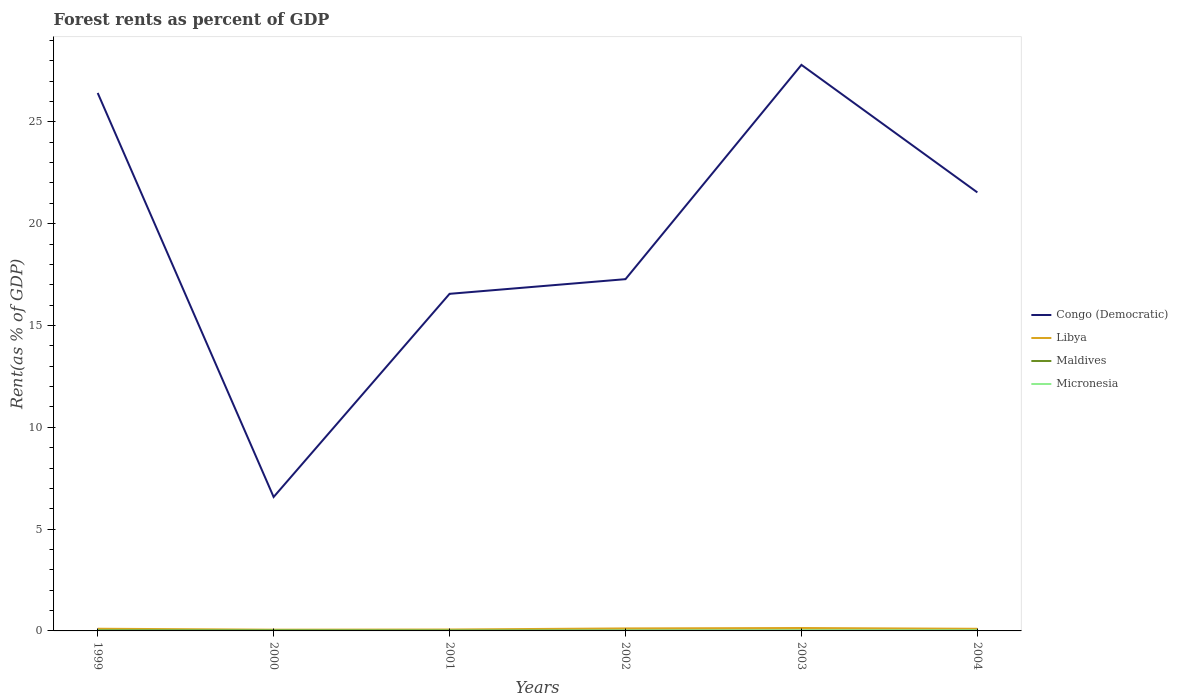Is the number of lines equal to the number of legend labels?
Provide a short and direct response. Yes. Across all years, what is the maximum forest rent in Congo (Democratic)?
Keep it short and to the point. 6.58. In which year was the forest rent in Micronesia maximum?
Provide a short and direct response. 1999. What is the total forest rent in Maldives in the graph?
Provide a succinct answer. 0. What is the difference between the highest and the second highest forest rent in Micronesia?
Offer a very short reply. 0.02. What is the difference between the highest and the lowest forest rent in Libya?
Ensure brevity in your answer.  4. Is the forest rent in Micronesia strictly greater than the forest rent in Maldives over the years?
Provide a short and direct response. No. How many lines are there?
Your response must be concise. 4. Are the values on the major ticks of Y-axis written in scientific E-notation?
Your answer should be very brief. No. Does the graph contain any zero values?
Your answer should be very brief. No. Does the graph contain grids?
Keep it short and to the point. No. How are the legend labels stacked?
Provide a succinct answer. Vertical. What is the title of the graph?
Provide a succinct answer. Forest rents as percent of GDP. Does "Barbados" appear as one of the legend labels in the graph?
Your answer should be very brief. No. What is the label or title of the X-axis?
Keep it short and to the point. Years. What is the label or title of the Y-axis?
Keep it short and to the point. Rent(as % of GDP). What is the Rent(as % of GDP) in Congo (Democratic) in 1999?
Give a very brief answer. 26.42. What is the Rent(as % of GDP) of Libya in 1999?
Give a very brief answer. 0.11. What is the Rent(as % of GDP) in Maldives in 1999?
Provide a succinct answer. 0.04. What is the Rent(as % of GDP) in Micronesia in 1999?
Provide a succinct answer. 0.01. What is the Rent(as % of GDP) in Congo (Democratic) in 2000?
Make the answer very short. 6.58. What is the Rent(as % of GDP) of Libya in 2000?
Your answer should be compact. 0.06. What is the Rent(as % of GDP) in Maldives in 2000?
Provide a short and direct response. 0.04. What is the Rent(as % of GDP) in Micronesia in 2000?
Keep it short and to the point. 0.01. What is the Rent(as % of GDP) of Congo (Democratic) in 2001?
Offer a terse response. 16.56. What is the Rent(as % of GDP) of Libya in 2001?
Provide a succinct answer. 0.07. What is the Rent(as % of GDP) of Maldives in 2001?
Provide a short and direct response. 0.03. What is the Rent(as % of GDP) of Micronesia in 2001?
Ensure brevity in your answer.  0.01. What is the Rent(as % of GDP) in Congo (Democratic) in 2002?
Make the answer very short. 17.28. What is the Rent(as % of GDP) in Libya in 2002?
Ensure brevity in your answer.  0.12. What is the Rent(as % of GDP) in Maldives in 2002?
Keep it short and to the point. 0.03. What is the Rent(as % of GDP) of Micronesia in 2002?
Provide a succinct answer. 0.01. What is the Rent(as % of GDP) in Congo (Democratic) in 2003?
Give a very brief answer. 27.8. What is the Rent(as % of GDP) in Libya in 2003?
Offer a terse response. 0.14. What is the Rent(as % of GDP) of Maldives in 2003?
Keep it short and to the point. 0.03. What is the Rent(as % of GDP) of Micronesia in 2003?
Provide a succinct answer. 0.02. What is the Rent(as % of GDP) of Congo (Democratic) in 2004?
Keep it short and to the point. 21.54. What is the Rent(as % of GDP) in Libya in 2004?
Your answer should be very brief. 0.11. What is the Rent(as % of GDP) of Maldives in 2004?
Provide a succinct answer. 0.02. What is the Rent(as % of GDP) of Micronesia in 2004?
Provide a succinct answer. 0.03. Across all years, what is the maximum Rent(as % of GDP) in Congo (Democratic)?
Provide a short and direct response. 27.8. Across all years, what is the maximum Rent(as % of GDP) in Libya?
Make the answer very short. 0.14. Across all years, what is the maximum Rent(as % of GDP) in Maldives?
Offer a very short reply. 0.04. Across all years, what is the maximum Rent(as % of GDP) of Micronesia?
Provide a short and direct response. 0.03. Across all years, what is the minimum Rent(as % of GDP) in Congo (Democratic)?
Offer a terse response. 6.58. Across all years, what is the minimum Rent(as % of GDP) in Libya?
Keep it short and to the point. 0.06. Across all years, what is the minimum Rent(as % of GDP) in Maldives?
Provide a short and direct response. 0.02. Across all years, what is the minimum Rent(as % of GDP) of Micronesia?
Keep it short and to the point. 0.01. What is the total Rent(as % of GDP) of Congo (Democratic) in the graph?
Offer a terse response. 116.17. What is the total Rent(as % of GDP) of Libya in the graph?
Your answer should be very brief. 0.61. What is the total Rent(as % of GDP) of Maldives in the graph?
Offer a very short reply. 0.18. What is the total Rent(as % of GDP) in Micronesia in the graph?
Give a very brief answer. 0.1. What is the difference between the Rent(as % of GDP) of Congo (Democratic) in 1999 and that in 2000?
Provide a short and direct response. 19.84. What is the difference between the Rent(as % of GDP) in Libya in 1999 and that in 2000?
Keep it short and to the point. 0.05. What is the difference between the Rent(as % of GDP) of Maldives in 1999 and that in 2000?
Ensure brevity in your answer.  0. What is the difference between the Rent(as % of GDP) in Micronesia in 1999 and that in 2000?
Ensure brevity in your answer.  -0. What is the difference between the Rent(as % of GDP) in Congo (Democratic) in 1999 and that in 2001?
Offer a very short reply. 9.87. What is the difference between the Rent(as % of GDP) in Libya in 1999 and that in 2001?
Provide a succinct answer. 0.04. What is the difference between the Rent(as % of GDP) in Maldives in 1999 and that in 2001?
Your answer should be compact. 0.01. What is the difference between the Rent(as % of GDP) of Micronesia in 1999 and that in 2001?
Your answer should be compact. -0. What is the difference between the Rent(as % of GDP) in Congo (Democratic) in 1999 and that in 2002?
Give a very brief answer. 9.14. What is the difference between the Rent(as % of GDP) in Libya in 1999 and that in 2002?
Keep it short and to the point. -0.02. What is the difference between the Rent(as % of GDP) of Maldives in 1999 and that in 2002?
Provide a short and direct response. 0.01. What is the difference between the Rent(as % of GDP) of Micronesia in 1999 and that in 2002?
Give a very brief answer. -0. What is the difference between the Rent(as % of GDP) of Congo (Democratic) in 1999 and that in 2003?
Make the answer very short. -1.38. What is the difference between the Rent(as % of GDP) of Libya in 1999 and that in 2003?
Your response must be concise. -0.04. What is the difference between the Rent(as % of GDP) of Maldives in 1999 and that in 2003?
Give a very brief answer. 0.01. What is the difference between the Rent(as % of GDP) of Micronesia in 1999 and that in 2003?
Your answer should be compact. -0.01. What is the difference between the Rent(as % of GDP) of Congo (Democratic) in 1999 and that in 2004?
Make the answer very short. 4.88. What is the difference between the Rent(as % of GDP) of Libya in 1999 and that in 2004?
Provide a succinct answer. 0. What is the difference between the Rent(as % of GDP) in Maldives in 1999 and that in 2004?
Make the answer very short. 0.01. What is the difference between the Rent(as % of GDP) of Micronesia in 1999 and that in 2004?
Offer a terse response. -0.02. What is the difference between the Rent(as % of GDP) in Congo (Democratic) in 2000 and that in 2001?
Your answer should be very brief. -9.98. What is the difference between the Rent(as % of GDP) in Libya in 2000 and that in 2001?
Keep it short and to the point. -0.01. What is the difference between the Rent(as % of GDP) of Maldives in 2000 and that in 2001?
Provide a short and direct response. 0.01. What is the difference between the Rent(as % of GDP) in Micronesia in 2000 and that in 2001?
Ensure brevity in your answer.  -0. What is the difference between the Rent(as % of GDP) in Congo (Democratic) in 2000 and that in 2002?
Keep it short and to the point. -10.7. What is the difference between the Rent(as % of GDP) of Libya in 2000 and that in 2002?
Your answer should be compact. -0.06. What is the difference between the Rent(as % of GDP) in Maldives in 2000 and that in 2002?
Offer a very short reply. 0.01. What is the difference between the Rent(as % of GDP) in Micronesia in 2000 and that in 2002?
Your answer should be compact. -0. What is the difference between the Rent(as % of GDP) in Congo (Democratic) in 2000 and that in 2003?
Offer a very short reply. -21.22. What is the difference between the Rent(as % of GDP) of Libya in 2000 and that in 2003?
Give a very brief answer. -0.08. What is the difference between the Rent(as % of GDP) in Maldives in 2000 and that in 2003?
Give a very brief answer. 0.01. What is the difference between the Rent(as % of GDP) in Micronesia in 2000 and that in 2003?
Make the answer very short. -0.01. What is the difference between the Rent(as % of GDP) of Congo (Democratic) in 2000 and that in 2004?
Ensure brevity in your answer.  -14.96. What is the difference between the Rent(as % of GDP) of Libya in 2000 and that in 2004?
Give a very brief answer. -0.04. What is the difference between the Rent(as % of GDP) of Maldives in 2000 and that in 2004?
Your response must be concise. 0.01. What is the difference between the Rent(as % of GDP) of Micronesia in 2000 and that in 2004?
Your answer should be very brief. -0.01. What is the difference between the Rent(as % of GDP) of Congo (Democratic) in 2001 and that in 2002?
Your response must be concise. -0.72. What is the difference between the Rent(as % of GDP) in Libya in 2001 and that in 2002?
Give a very brief answer. -0.05. What is the difference between the Rent(as % of GDP) in Maldives in 2001 and that in 2002?
Your answer should be compact. 0. What is the difference between the Rent(as % of GDP) in Micronesia in 2001 and that in 2002?
Ensure brevity in your answer.  -0. What is the difference between the Rent(as % of GDP) of Congo (Democratic) in 2001 and that in 2003?
Provide a short and direct response. -11.25. What is the difference between the Rent(as % of GDP) in Libya in 2001 and that in 2003?
Provide a succinct answer. -0.07. What is the difference between the Rent(as % of GDP) in Maldives in 2001 and that in 2003?
Make the answer very short. 0. What is the difference between the Rent(as % of GDP) in Micronesia in 2001 and that in 2003?
Your answer should be compact. -0.01. What is the difference between the Rent(as % of GDP) of Congo (Democratic) in 2001 and that in 2004?
Provide a succinct answer. -4.98. What is the difference between the Rent(as % of GDP) in Libya in 2001 and that in 2004?
Your answer should be compact. -0.04. What is the difference between the Rent(as % of GDP) in Maldives in 2001 and that in 2004?
Your answer should be very brief. 0. What is the difference between the Rent(as % of GDP) in Micronesia in 2001 and that in 2004?
Give a very brief answer. -0.01. What is the difference between the Rent(as % of GDP) of Congo (Democratic) in 2002 and that in 2003?
Keep it short and to the point. -10.52. What is the difference between the Rent(as % of GDP) of Libya in 2002 and that in 2003?
Offer a very short reply. -0.02. What is the difference between the Rent(as % of GDP) of Maldives in 2002 and that in 2003?
Ensure brevity in your answer.  0. What is the difference between the Rent(as % of GDP) of Micronesia in 2002 and that in 2003?
Offer a terse response. -0.01. What is the difference between the Rent(as % of GDP) of Congo (Democratic) in 2002 and that in 2004?
Offer a very short reply. -4.26. What is the difference between the Rent(as % of GDP) of Libya in 2002 and that in 2004?
Give a very brief answer. 0.02. What is the difference between the Rent(as % of GDP) of Maldives in 2002 and that in 2004?
Ensure brevity in your answer.  0. What is the difference between the Rent(as % of GDP) of Micronesia in 2002 and that in 2004?
Your response must be concise. -0.01. What is the difference between the Rent(as % of GDP) in Congo (Democratic) in 2003 and that in 2004?
Offer a terse response. 6.26. What is the difference between the Rent(as % of GDP) in Libya in 2003 and that in 2004?
Provide a succinct answer. 0.04. What is the difference between the Rent(as % of GDP) in Maldives in 2003 and that in 2004?
Make the answer very short. 0. What is the difference between the Rent(as % of GDP) of Micronesia in 2003 and that in 2004?
Offer a very short reply. -0. What is the difference between the Rent(as % of GDP) in Congo (Democratic) in 1999 and the Rent(as % of GDP) in Libya in 2000?
Give a very brief answer. 26.36. What is the difference between the Rent(as % of GDP) in Congo (Democratic) in 1999 and the Rent(as % of GDP) in Maldives in 2000?
Your answer should be compact. 26.38. What is the difference between the Rent(as % of GDP) in Congo (Democratic) in 1999 and the Rent(as % of GDP) in Micronesia in 2000?
Make the answer very short. 26.41. What is the difference between the Rent(as % of GDP) in Libya in 1999 and the Rent(as % of GDP) in Maldives in 2000?
Offer a terse response. 0.07. What is the difference between the Rent(as % of GDP) of Libya in 1999 and the Rent(as % of GDP) of Micronesia in 2000?
Give a very brief answer. 0.1. What is the difference between the Rent(as % of GDP) in Maldives in 1999 and the Rent(as % of GDP) in Micronesia in 2000?
Provide a short and direct response. 0.03. What is the difference between the Rent(as % of GDP) of Congo (Democratic) in 1999 and the Rent(as % of GDP) of Libya in 2001?
Provide a succinct answer. 26.35. What is the difference between the Rent(as % of GDP) in Congo (Democratic) in 1999 and the Rent(as % of GDP) in Maldives in 2001?
Keep it short and to the point. 26.39. What is the difference between the Rent(as % of GDP) of Congo (Democratic) in 1999 and the Rent(as % of GDP) of Micronesia in 2001?
Ensure brevity in your answer.  26.41. What is the difference between the Rent(as % of GDP) in Libya in 1999 and the Rent(as % of GDP) in Maldives in 2001?
Your answer should be compact. 0.08. What is the difference between the Rent(as % of GDP) in Libya in 1999 and the Rent(as % of GDP) in Micronesia in 2001?
Keep it short and to the point. 0.1. What is the difference between the Rent(as % of GDP) in Maldives in 1999 and the Rent(as % of GDP) in Micronesia in 2001?
Provide a short and direct response. 0.03. What is the difference between the Rent(as % of GDP) in Congo (Democratic) in 1999 and the Rent(as % of GDP) in Libya in 2002?
Your response must be concise. 26.3. What is the difference between the Rent(as % of GDP) of Congo (Democratic) in 1999 and the Rent(as % of GDP) of Maldives in 2002?
Offer a terse response. 26.39. What is the difference between the Rent(as % of GDP) of Congo (Democratic) in 1999 and the Rent(as % of GDP) of Micronesia in 2002?
Keep it short and to the point. 26.41. What is the difference between the Rent(as % of GDP) in Libya in 1999 and the Rent(as % of GDP) in Maldives in 2002?
Make the answer very short. 0.08. What is the difference between the Rent(as % of GDP) in Libya in 1999 and the Rent(as % of GDP) in Micronesia in 2002?
Offer a very short reply. 0.09. What is the difference between the Rent(as % of GDP) in Maldives in 1999 and the Rent(as % of GDP) in Micronesia in 2002?
Make the answer very short. 0.02. What is the difference between the Rent(as % of GDP) in Congo (Democratic) in 1999 and the Rent(as % of GDP) in Libya in 2003?
Provide a succinct answer. 26.28. What is the difference between the Rent(as % of GDP) of Congo (Democratic) in 1999 and the Rent(as % of GDP) of Maldives in 2003?
Provide a succinct answer. 26.39. What is the difference between the Rent(as % of GDP) in Congo (Democratic) in 1999 and the Rent(as % of GDP) in Micronesia in 2003?
Your answer should be compact. 26.4. What is the difference between the Rent(as % of GDP) in Libya in 1999 and the Rent(as % of GDP) in Maldives in 2003?
Offer a very short reply. 0.08. What is the difference between the Rent(as % of GDP) in Libya in 1999 and the Rent(as % of GDP) in Micronesia in 2003?
Ensure brevity in your answer.  0.09. What is the difference between the Rent(as % of GDP) in Maldives in 1999 and the Rent(as % of GDP) in Micronesia in 2003?
Keep it short and to the point. 0.02. What is the difference between the Rent(as % of GDP) in Congo (Democratic) in 1999 and the Rent(as % of GDP) in Libya in 2004?
Your answer should be very brief. 26.32. What is the difference between the Rent(as % of GDP) of Congo (Democratic) in 1999 and the Rent(as % of GDP) of Maldives in 2004?
Offer a terse response. 26.4. What is the difference between the Rent(as % of GDP) of Congo (Democratic) in 1999 and the Rent(as % of GDP) of Micronesia in 2004?
Your response must be concise. 26.39. What is the difference between the Rent(as % of GDP) in Libya in 1999 and the Rent(as % of GDP) in Maldives in 2004?
Ensure brevity in your answer.  0.08. What is the difference between the Rent(as % of GDP) of Libya in 1999 and the Rent(as % of GDP) of Micronesia in 2004?
Make the answer very short. 0.08. What is the difference between the Rent(as % of GDP) in Maldives in 1999 and the Rent(as % of GDP) in Micronesia in 2004?
Provide a short and direct response. 0.01. What is the difference between the Rent(as % of GDP) in Congo (Democratic) in 2000 and the Rent(as % of GDP) in Libya in 2001?
Your answer should be very brief. 6.51. What is the difference between the Rent(as % of GDP) in Congo (Democratic) in 2000 and the Rent(as % of GDP) in Maldives in 2001?
Your response must be concise. 6.55. What is the difference between the Rent(as % of GDP) in Congo (Democratic) in 2000 and the Rent(as % of GDP) in Micronesia in 2001?
Ensure brevity in your answer.  6.57. What is the difference between the Rent(as % of GDP) of Libya in 2000 and the Rent(as % of GDP) of Maldives in 2001?
Keep it short and to the point. 0.03. What is the difference between the Rent(as % of GDP) in Libya in 2000 and the Rent(as % of GDP) in Micronesia in 2001?
Ensure brevity in your answer.  0.05. What is the difference between the Rent(as % of GDP) in Maldives in 2000 and the Rent(as % of GDP) in Micronesia in 2001?
Offer a terse response. 0.03. What is the difference between the Rent(as % of GDP) of Congo (Democratic) in 2000 and the Rent(as % of GDP) of Libya in 2002?
Provide a succinct answer. 6.45. What is the difference between the Rent(as % of GDP) of Congo (Democratic) in 2000 and the Rent(as % of GDP) of Maldives in 2002?
Ensure brevity in your answer.  6.55. What is the difference between the Rent(as % of GDP) in Congo (Democratic) in 2000 and the Rent(as % of GDP) in Micronesia in 2002?
Keep it short and to the point. 6.56. What is the difference between the Rent(as % of GDP) of Libya in 2000 and the Rent(as % of GDP) of Maldives in 2002?
Offer a terse response. 0.03. What is the difference between the Rent(as % of GDP) in Libya in 2000 and the Rent(as % of GDP) in Micronesia in 2002?
Provide a short and direct response. 0.05. What is the difference between the Rent(as % of GDP) in Maldives in 2000 and the Rent(as % of GDP) in Micronesia in 2002?
Your response must be concise. 0.02. What is the difference between the Rent(as % of GDP) in Congo (Democratic) in 2000 and the Rent(as % of GDP) in Libya in 2003?
Offer a terse response. 6.43. What is the difference between the Rent(as % of GDP) in Congo (Democratic) in 2000 and the Rent(as % of GDP) in Maldives in 2003?
Offer a very short reply. 6.55. What is the difference between the Rent(as % of GDP) of Congo (Democratic) in 2000 and the Rent(as % of GDP) of Micronesia in 2003?
Ensure brevity in your answer.  6.56. What is the difference between the Rent(as % of GDP) of Libya in 2000 and the Rent(as % of GDP) of Maldives in 2003?
Offer a very short reply. 0.03. What is the difference between the Rent(as % of GDP) of Libya in 2000 and the Rent(as % of GDP) of Micronesia in 2003?
Provide a short and direct response. 0.04. What is the difference between the Rent(as % of GDP) in Maldives in 2000 and the Rent(as % of GDP) in Micronesia in 2003?
Your answer should be compact. 0.01. What is the difference between the Rent(as % of GDP) in Congo (Democratic) in 2000 and the Rent(as % of GDP) in Libya in 2004?
Your answer should be compact. 6.47. What is the difference between the Rent(as % of GDP) of Congo (Democratic) in 2000 and the Rent(as % of GDP) of Maldives in 2004?
Offer a terse response. 6.55. What is the difference between the Rent(as % of GDP) of Congo (Democratic) in 2000 and the Rent(as % of GDP) of Micronesia in 2004?
Offer a terse response. 6.55. What is the difference between the Rent(as % of GDP) of Libya in 2000 and the Rent(as % of GDP) of Maldives in 2004?
Ensure brevity in your answer.  0.04. What is the difference between the Rent(as % of GDP) in Libya in 2000 and the Rent(as % of GDP) in Micronesia in 2004?
Provide a succinct answer. 0.03. What is the difference between the Rent(as % of GDP) in Maldives in 2000 and the Rent(as % of GDP) in Micronesia in 2004?
Make the answer very short. 0.01. What is the difference between the Rent(as % of GDP) of Congo (Democratic) in 2001 and the Rent(as % of GDP) of Libya in 2002?
Your answer should be very brief. 16.43. What is the difference between the Rent(as % of GDP) of Congo (Democratic) in 2001 and the Rent(as % of GDP) of Maldives in 2002?
Make the answer very short. 16.53. What is the difference between the Rent(as % of GDP) of Congo (Democratic) in 2001 and the Rent(as % of GDP) of Micronesia in 2002?
Your answer should be very brief. 16.54. What is the difference between the Rent(as % of GDP) in Libya in 2001 and the Rent(as % of GDP) in Maldives in 2002?
Provide a short and direct response. 0.04. What is the difference between the Rent(as % of GDP) of Libya in 2001 and the Rent(as % of GDP) of Micronesia in 2002?
Provide a succinct answer. 0.06. What is the difference between the Rent(as % of GDP) in Maldives in 2001 and the Rent(as % of GDP) in Micronesia in 2002?
Offer a terse response. 0.01. What is the difference between the Rent(as % of GDP) in Congo (Democratic) in 2001 and the Rent(as % of GDP) in Libya in 2003?
Your answer should be compact. 16.41. What is the difference between the Rent(as % of GDP) in Congo (Democratic) in 2001 and the Rent(as % of GDP) in Maldives in 2003?
Ensure brevity in your answer.  16.53. What is the difference between the Rent(as % of GDP) in Congo (Democratic) in 2001 and the Rent(as % of GDP) in Micronesia in 2003?
Provide a short and direct response. 16.53. What is the difference between the Rent(as % of GDP) in Libya in 2001 and the Rent(as % of GDP) in Maldives in 2003?
Your response must be concise. 0.04. What is the difference between the Rent(as % of GDP) of Libya in 2001 and the Rent(as % of GDP) of Micronesia in 2003?
Make the answer very short. 0.05. What is the difference between the Rent(as % of GDP) of Maldives in 2001 and the Rent(as % of GDP) of Micronesia in 2003?
Make the answer very short. 0. What is the difference between the Rent(as % of GDP) of Congo (Democratic) in 2001 and the Rent(as % of GDP) of Libya in 2004?
Your answer should be compact. 16.45. What is the difference between the Rent(as % of GDP) in Congo (Democratic) in 2001 and the Rent(as % of GDP) in Maldives in 2004?
Your answer should be very brief. 16.53. What is the difference between the Rent(as % of GDP) of Congo (Democratic) in 2001 and the Rent(as % of GDP) of Micronesia in 2004?
Make the answer very short. 16.53. What is the difference between the Rent(as % of GDP) in Libya in 2001 and the Rent(as % of GDP) in Maldives in 2004?
Keep it short and to the point. 0.04. What is the difference between the Rent(as % of GDP) of Libya in 2001 and the Rent(as % of GDP) of Micronesia in 2004?
Your answer should be very brief. 0.04. What is the difference between the Rent(as % of GDP) in Maldives in 2001 and the Rent(as % of GDP) in Micronesia in 2004?
Your response must be concise. 0. What is the difference between the Rent(as % of GDP) in Congo (Democratic) in 2002 and the Rent(as % of GDP) in Libya in 2003?
Ensure brevity in your answer.  17.13. What is the difference between the Rent(as % of GDP) in Congo (Democratic) in 2002 and the Rent(as % of GDP) in Maldives in 2003?
Provide a short and direct response. 17.25. What is the difference between the Rent(as % of GDP) in Congo (Democratic) in 2002 and the Rent(as % of GDP) in Micronesia in 2003?
Keep it short and to the point. 17.25. What is the difference between the Rent(as % of GDP) in Libya in 2002 and the Rent(as % of GDP) in Maldives in 2003?
Provide a short and direct response. 0.1. What is the difference between the Rent(as % of GDP) of Libya in 2002 and the Rent(as % of GDP) of Micronesia in 2003?
Provide a succinct answer. 0.1. What is the difference between the Rent(as % of GDP) of Maldives in 2002 and the Rent(as % of GDP) of Micronesia in 2003?
Provide a succinct answer. 0. What is the difference between the Rent(as % of GDP) of Congo (Democratic) in 2002 and the Rent(as % of GDP) of Libya in 2004?
Provide a succinct answer. 17.17. What is the difference between the Rent(as % of GDP) in Congo (Democratic) in 2002 and the Rent(as % of GDP) in Maldives in 2004?
Make the answer very short. 17.25. What is the difference between the Rent(as % of GDP) in Congo (Democratic) in 2002 and the Rent(as % of GDP) in Micronesia in 2004?
Your response must be concise. 17.25. What is the difference between the Rent(as % of GDP) in Libya in 2002 and the Rent(as % of GDP) in Maldives in 2004?
Provide a short and direct response. 0.1. What is the difference between the Rent(as % of GDP) of Libya in 2002 and the Rent(as % of GDP) of Micronesia in 2004?
Your response must be concise. 0.1. What is the difference between the Rent(as % of GDP) in Maldives in 2002 and the Rent(as % of GDP) in Micronesia in 2004?
Ensure brevity in your answer.  0. What is the difference between the Rent(as % of GDP) of Congo (Democratic) in 2003 and the Rent(as % of GDP) of Libya in 2004?
Your answer should be compact. 27.7. What is the difference between the Rent(as % of GDP) of Congo (Democratic) in 2003 and the Rent(as % of GDP) of Maldives in 2004?
Give a very brief answer. 27.78. What is the difference between the Rent(as % of GDP) in Congo (Democratic) in 2003 and the Rent(as % of GDP) in Micronesia in 2004?
Provide a succinct answer. 27.77. What is the difference between the Rent(as % of GDP) in Libya in 2003 and the Rent(as % of GDP) in Maldives in 2004?
Your answer should be very brief. 0.12. What is the difference between the Rent(as % of GDP) in Libya in 2003 and the Rent(as % of GDP) in Micronesia in 2004?
Offer a very short reply. 0.12. What is the average Rent(as % of GDP) in Congo (Democratic) per year?
Keep it short and to the point. 19.36. What is the average Rent(as % of GDP) in Libya per year?
Your answer should be very brief. 0.1. What is the average Rent(as % of GDP) in Maldives per year?
Provide a succinct answer. 0.03. What is the average Rent(as % of GDP) in Micronesia per year?
Provide a succinct answer. 0.02. In the year 1999, what is the difference between the Rent(as % of GDP) in Congo (Democratic) and Rent(as % of GDP) in Libya?
Your answer should be very brief. 26.31. In the year 1999, what is the difference between the Rent(as % of GDP) of Congo (Democratic) and Rent(as % of GDP) of Maldives?
Offer a terse response. 26.38. In the year 1999, what is the difference between the Rent(as % of GDP) in Congo (Democratic) and Rent(as % of GDP) in Micronesia?
Provide a short and direct response. 26.41. In the year 1999, what is the difference between the Rent(as % of GDP) in Libya and Rent(as % of GDP) in Maldives?
Your answer should be compact. 0.07. In the year 1999, what is the difference between the Rent(as % of GDP) of Libya and Rent(as % of GDP) of Micronesia?
Your response must be concise. 0.1. In the year 1999, what is the difference between the Rent(as % of GDP) in Maldives and Rent(as % of GDP) in Micronesia?
Offer a terse response. 0.03. In the year 2000, what is the difference between the Rent(as % of GDP) in Congo (Democratic) and Rent(as % of GDP) in Libya?
Provide a short and direct response. 6.52. In the year 2000, what is the difference between the Rent(as % of GDP) of Congo (Democratic) and Rent(as % of GDP) of Maldives?
Offer a very short reply. 6.54. In the year 2000, what is the difference between the Rent(as % of GDP) of Congo (Democratic) and Rent(as % of GDP) of Micronesia?
Provide a succinct answer. 6.57. In the year 2000, what is the difference between the Rent(as % of GDP) in Libya and Rent(as % of GDP) in Maldives?
Offer a very short reply. 0.02. In the year 2000, what is the difference between the Rent(as % of GDP) of Libya and Rent(as % of GDP) of Micronesia?
Keep it short and to the point. 0.05. In the year 2000, what is the difference between the Rent(as % of GDP) of Maldives and Rent(as % of GDP) of Micronesia?
Offer a very short reply. 0.03. In the year 2001, what is the difference between the Rent(as % of GDP) in Congo (Democratic) and Rent(as % of GDP) in Libya?
Give a very brief answer. 16.49. In the year 2001, what is the difference between the Rent(as % of GDP) in Congo (Democratic) and Rent(as % of GDP) in Maldives?
Your answer should be very brief. 16.53. In the year 2001, what is the difference between the Rent(as % of GDP) in Congo (Democratic) and Rent(as % of GDP) in Micronesia?
Offer a very short reply. 16.54. In the year 2001, what is the difference between the Rent(as % of GDP) of Libya and Rent(as % of GDP) of Maldives?
Provide a short and direct response. 0.04. In the year 2001, what is the difference between the Rent(as % of GDP) in Libya and Rent(as % of GDP) in Micronesia?
Provide a short and direct response. 0.06. In the year 2001, what is the difference between the Rent(as % of GDP) of Maldives and Rent(as % of GDP) of Micronesia?
Keep it short and to the point. 0.01. In the year 2002, what is the difference between the Rent(as % of GDP) of Congo (Democratic) and Rent(as % of GDP) of Libya?
Make the answer very short. 17.15. In the year 2002, what is the difference between the Rent(as % of GDP) of Congo (Democratic) and Rent(as % of GDP) of Maldives?
Provide a short and direct response. 17.25. In the year 2002, what is the difference between the Rent(as % of GDP) of Congo (Democratic) and Rent(as % of GDP) of Micronesia?
Make the answer very short. 17.26. In the year 2002, what is the difference between the Rent(as % of GDP) in Libya and Rent(as % of GDP) in Maldives?
Offer a very short reply. 0.1. In the year 2002, what is the difference between the Rent(as % of GDP) of Libya and Rent(as % of GDP) of Micronesia?
Your response must be concise. 0.11. In the year 2002, what is the difference between the Rent(as % of GDP) in Maldives and Rent(as % of GDP) in Micronesia?
Provide a short and direct response. 0.01. In the year 2003, what is the difference between the Rent(as % of GDP) of Congo (Democratic) and Rent(as % of GDP) of Libya?
Your answer should be compact. 27.66. In the year 2003, what is the difference between the Rent(as % of GDP) in Congo (Democratic) and Rent(as % of GDP) in Maldives?
Provide a succinct answer. 27.77. In the year 2003, what is the difference between the Rent(as % of GDP) in Congo (Democratic) and Rent(as % of GDP) in Micronesia?
Ensure brevity in your answer.  27.78. In the year 2003, what is the difference between the Rent(as % of GDP) in Libya and Rent(as % of GDP) in Maldives?
Your response must be concise. 0.12. In the year 2003, what is the difference between the Rent(as % of GDP) of Libya and Rent(as % of GDP) of Micronesia?
Your answer should be compact. 0.12. In the year 2003, what is the difference between the Rent(as % of GDP) of Maldives and Rent(as % of GDP) of Micronesia?
Give a very brief answer. 0. In the year 2004, what is the difference between the Rent(as % of GDP) in Congo (Democratic) and Rent(as % of GDP) in Libya?
Ensure brevity in your answer.  21.43. In the year 2004, what is the difference between the Rent(as % of GDP) of Congo (Democratic) and Rent(as % of GDP) of Maldives?
Give a very brief answer. 21.51. In the year 2004, what is the difference between the Rent(as % of GDP) of Congo (Democratic) and Rent(as % of GDP) of Micronesia?
Ensure brevity in your answer.  21.51. In the year 2004, what is the difference between the Rent(as % of GDP) in Libya and Rent(as % of GDP) in Maldives?
Your answer should be compact. 0.08. In the year 2004, what is the difference between the Rent(as % of GDP) in Libya and Rent(as % of GDP) in Micronesia?
Provide a succinct answer. 0.08. In the year 2004, what is the difference between the Rent(as % of GDP) in Maldives and Rent(as % of GDP) in Micronesia?
Your answer should be very brief. -0. What is the ratio of the Rent(as % of GDP) in Congo (Democratic) in 1999 to that in 2000?
Provide a short and direct response. 4.02. What is the ratio of the Rent(as % of GDP) of Libya in 1999 to that in 2000?
Keep it short and to the point. 1.78. What is the ratio of the Rent(as % of GDP) in Maldives in 1999 to that in 2000?
Your answer should be very brief. 1.01. What is the ratio of the Rent(as % of GDP) of Micronesia in 1999 to that in 2000?
Your response must be concise. 0.94. What is the ratio of the Rent(as % of GDP) of Congo (Democratic) in 1999 to that in 2001?
Provide a short and direct response. 1.6. What is the ratio of the Rent(as % of GDP) in Libya in 1999 to that in 2001?
Offer a terse response. 1.56. What is the ratio of the Rent(as % of GDP) of Maldives in 1999 to that in 2001?
Provide a succinct answer. 1.41. What is the ratio of the Rent(as % of GDP) of Micronesia in 1999 to that in 2001?
Provide a short and direct response. 0.88. What is the ratio of the Rent(as % of GDP) of Congo (Democratic) in 1999 to that in 2002?
Make the answer very short. 1.53. What is the ratio of the Rent(as % of GDP) of Libya in 1999 to that in 2002?
Keep it short and to the point. 0.87. What is the ratio of the Rent(as % of GDP) of Maldives in 1999 to that in 2002?
Your answer should be very brief. 1.43. What is the ratio of the Rent(as % of GDP) in Micronesia in 1999 to that in 2002?
Your response must be concise. 0.78. What is the ratio of the Rent(as % of GDP) of Congo (Democratic) in 1999 to that in 2003?
Offer a terse response. 0.95. What is the ratio of the Rent(as % of GDP) in Libya in 1999 to that in 2003?
Keep it short and to the point. 0.75. What is the ratio of the Rent(as % of GDP) in Maldives in 1999 to that in 2003?
Ensure brevity in your answer.  1.45. What is the ratio of the Rent(as % of GDP) of Micronesia in 1999 to that in 2003?
Provide a succinct answer. 0.47. What is the ratio of the Rent(as % of GDP) in Congo (Democratic) in 1999 to that in 2004?
Keep it short and to the point. 1.23. What is the ratio of the Rent(as % of GDP) of Libya in 1999 to that in 2004?
Provide a short and direct response. 1.02. What is the ratio of the Rent(as % of GDP) of Maldives in 1999 to that in 2004?
Provide a succinct answer. 1.57. What is the ratio of the Rent(as % of GDP) of Micronesia in 1999 to that in 2004?
Provide a short and direct response. 0.4. What is the ratio of the Rent(as % of GDP) of Congo (Democratic) in 2000 to that in 2001?
Your answer should be compact. 0.4. What is the ratio of the Rent(as % of GDP) of Libya in 2000 to that in 2001?
Your response must be concise. 0.88. What is the ratio of the Rent(as % of GDP) in Maldives in 2000 to that in 2001?
Offer a very short reply. 1.39. What is the ratio of the Rent(as % of GDP) of Micronesia in 2000 to that in 2001?
Make the answer very short. 0.94. What is the ratio of the Rent(as % of GDP) in Congo (Democratic) in 2000 to that in 2002?
Your answer should be very brief. 0.38. What is the ratio of the Rent(as % of GDP) of Libya in 2000 to that in 2002?
Your response must be concise. 0.49. What is the ratio of the Rent(as % of GDP) of Maldives in 2000 to that in 2002?
Offer a terse response. 1.41. What is the ratio of the Rent(as % of GDP) of Micronesia in 2000 to that in 2002?
Make the answer very short. 0.83. What is the ratio of the Rent(as % of GDP) in Congo (Democratic) in 2000 to that in 2003?
Provide a succinct answer. 0.24. What is the ratio of the Rent(as % of GDP) of Libya in 2000 to that in 2003?
Your response must be concise. 0.42. What is the ratio of the Rent(as % of GDP) in Maldives in 2000 to that in 2003?
Ensure brevity in your answer.  1.43. What is the ratio of the Rent(as % of GDP) in Micronesia in 2000 to that in 2003?
Make the answer very short. 0.5. What is the ratio of the Rent(as % of GDP) of Congo (Democratic) in 2000 to that in 2004?
Provide a succinct answer. 0.31. What is the ratio of the Rent(as % of GDP) of Libya in 2000 to that in 2004?
Offer a terse response. 0.57. What is the ratio of the Rent(as % of GDP) of Maldives in 2000 to that in 2004?
Your answer should be compact. 1.55. What is the ratio of the Rent(as % of GDP) of Micronesia in 2000 to that in 2004?
Your answer should be compact. 0.43. What is the ratio of the Rent(as % of GDP) in Libya in 2001 to that in 2002?
Ensure brevity in your answer.  0.56. What is the ratio of the Rent(as % of GDP) of Maldives in 2001 to that in 2002?
Your response must be concise. 1.01. What is the ratio of the Rent(as % of GDP) in Micronesia in 2001 to that in 2002?
Keep it short and to the point. 0.89. What is the ratio of the Rent(as % of GDP) in Congo (Democratic) in 2001 to that in 2003?
Your answer should be compact. 0.6. What is the ratio of the Rent(as % of GDP) in Libya in 2001 to that in 2003?
Offer a very short reply. 0.48. What is the ratio of the Rent(as % of GDP) of Maldives in 2001 to that in 2003?
Your answer should be very brief. 1.02. What is the ratio of the Rent(as % of GDP) of Micronesia in 2001 to that in 2003?
Make the answer very short. 0.53. What is the ratio of the Rent(as % of GDP) in Congo (Democratic) in 2001 to that in 2004?
Offer a very short reply. 0.77. What is the ratio of the Rent(as % of GDP) in Libya in 2001 to that in 2004?
Offer a very short reply. 0.65. What is the ratio of the Rent(as % of GDP) of Maldives in 2001 to that in 2004?
Provide a short and direct response. 1.12. What is the ratio of the Rent(as % of GDP) of Micronesia in 2001 to that in 2004?
Ensure brevity in your answer.  0.46. What is the ratio of the Rent(as % of GDP) of Congo (Democratic) in 2002 to that in 2003?
Provide a succinct answer. 0.62. What is the ratio of the Rent(as % of GDP) of Libya in 2002 to that in 2003?
Offer a very short reply. 0.86. What is the ratio of the Rent(as % of GDP) of Maldives in 2002 to that in 2003?
Offer a very short reply. 1.01. What is the ratio of the Rent(as % of GDP) in Micronesia in 2002 to that in 2003?
Give a very brief answer. 0.6. What is the ratio of the Rent(as % of GDP) in Congo (Democratic) in 2002 to that in 2004?
Provide a succinct answer. 0.8. What is the ratio of the Rent(as % of GDP) in Libya in 2002 to that in 2004?
Make the answer very short. 1.17. What is the ratio of the Rent(as % of GDP) in Maldives in 2002 to that in 2004?
Offer a terse response. 1.1. What is the ratio of the Rent(as % of GDP) of Micronesia in 2002 to that in 2004?
Your response must be concise. 0.52. What is the ratio of the Rent(as % of GDP) in Congo (Democratic) in 2003 to that in 2004?
Your answer should be very brief. 1.29. What is the ratio of the Rent(as % of GDP) of Libya in 2003 to that in 2004?
Your answer should be very brief. 1.37. What is the ratio of the Rent(as % of GDP) in Maldives in 2003 to that in 2004?
Your answer should be compact. 1.09. What is the ratio of the Rent(as % of GDP) of Micronesia in 2003 to that in 2004?
Keep it short and to the point. 0.86. What is the difference between the highest and the second highest Rent(as % of GDP) of Congo (Democratic)?
Ensure brevity in your answer.  1.38. What is the difference between the highest and the second highest Rent(as % of GDP) of Libya?
Make the answer very short. 0.02. What is the difference between the highest and the second highest Rent(as % of GDP) of Micronesia?
Your response must be concise. 0. What is the difference between the highest and the lowest Rent(as % of GDP) of Congo (Democratic)?
Your answer should be compact. 21.22. What is the difference between the highest and the lowest Rent(as % of GDP) in Libya?
Offer a terse response. 0.08. What is the difference between the highest and the lowest Rent(as % of GDP) in Maldives?
Offer a terse response. 0.01. What is the difference between the highest and the lowest Rent(as % of GDP) in Micronesia?
Give a very brief answer. 0.02. 